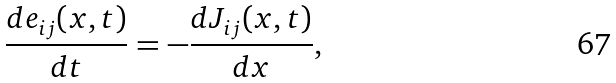Convert formula to latex. <formula><loc_0><loc_0><loc_500><loc_500>\frac { d e _ { i j } ( x , t ) } { d t } = - \frac { d J _ { i j } ( x , t ) } { d x } ,</formula> 